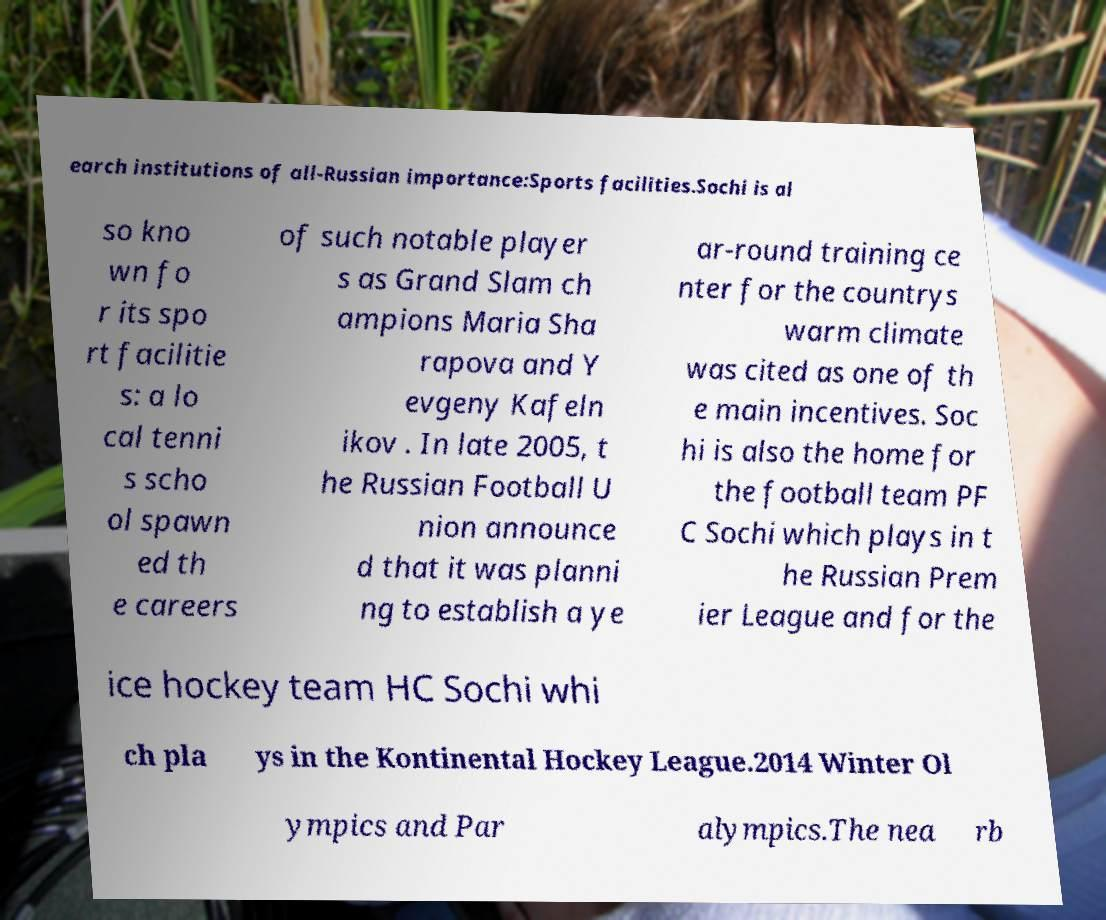Please identify and transcribe the text found in this image. earch institutions of all-Russian importance:Sports facilities.Sochi is al so kno wn fo r its spo rt facilitie s: a lo cal tenni s scho ol spawn ed th e careers of such notable player s as Grand Slam ch ampions Maria Sha rapova and Y evgeny Kafeln ikov . In late 2005, t he Russian Football U nion announce d that it was planni ng to establish a ye ar-round training ce nter for the countrys warm climate was cited as one of th e main incentives. Soc hi is also the home for the football team PF C Sochi which plays in t he Russian Prem ier League and for the ice hockey team HC Sochi whi ch pla ys in the Kontinental Hockey League.2014 Winter Ol ympics and Par alympics.The nea rb 